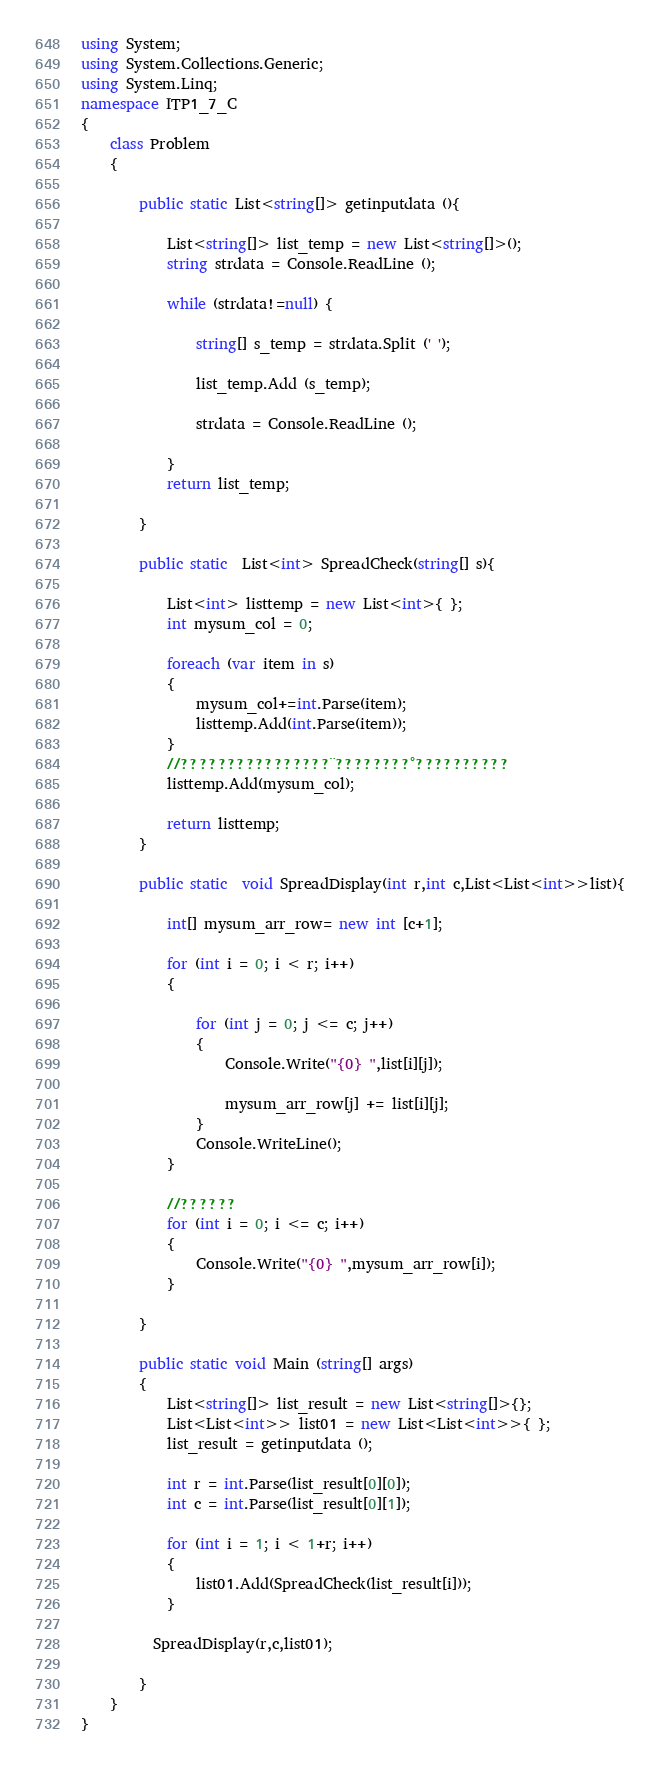<code> <loc_0><loc_0><loc_500><loc_500><_C#_>using System;
using System.Collections.Generic;
using System.Linq;
namespace ITP1_7_C
{
    class Problem
    {

        public static List<string[]> getinputdata (){

            List<string[]> list_temp = new List<string[]>();
            string strdata = Console.ReadLine ();

            while (strdata!=null) {

                string[] s_temp = strdata.Split (' ');

                list_temp.Add (s_temp);

                strdata = Console.ReadLine ();

            }
            return list_temp;

        }

        public static  List<int> SpreadCheck(string[] s){
            
            List<int> listtemp = new List<int>{ };
            int mysum_col = 0;
           
            foreach (var item in s)
            {
                mysum_col+=int.Parse(item);
                listtemp.Add(int.Parse(item));
            }
            //????????????????¨????????°??????????
            listtemp.Add(mysum_col);

            return listtemp;
        }

        public static  void SpreadDisplay(int r,int c,List<List<int>>list){

            int[] mysum_arr_row= new int [c+1];

            for (int i = 0; i < r; i++)
            {
                
                for (int j = 0; j <= c; j++)
                {
                    Console.Write("{0} ",list[i][j]);

                    mysum_arr_row[j] += list[i][j];
                }
                Console.WriteLine();
            }

            //??????
            for (int i = 0; i <= c; i++)
            {                
                Console.Write("{0} ",mysum_arr_row[i]);
            }

        }

        public static void Main (string[] args)
        {
            List<string[]> list_result = new List<string[]>{};
            List<List<int>> list01 = new List<List<int>>{ };
            list_result = getinputdata ();

            int r = int.Parse(list_result[0][0]);
            int c = int.Parse(list_result[0][1]);

            for (int i = 1; i < 1+r; i++)
            {
                list01.Add(SpreadCheck(list_result[i]));
            }

          SpreadDisplay(r,c,list01);

        }
    }
}</code> 